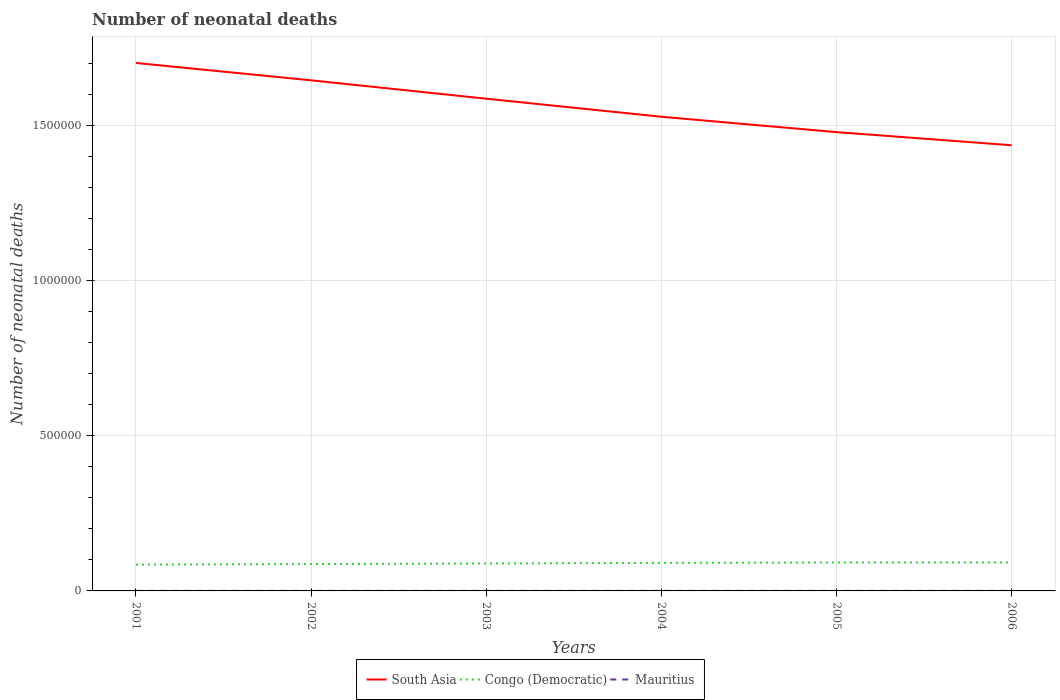Does the line corresponding to Congo (Democratic) intersect with the line corresponding to Mauritius?
Provide a succinct answer. No. Across all years, what is the maximum number of neonatal deaths in in Congo (Democratic)?
Your answer should be compact. 8.47e+04. What is the total number of neonatal deaths in in South Asia in the graph?
Your answer should be compact. 5.59e+04. What is the difference between the highest and the second highest number of neonatal deaths in in Congo (Democratic)?
Make the answer very short. 6965. What is the difference between the highest and the lowest number of neonatal deaths in in Mauritius?
Provide a short and direct response. 3. Is the number of neonatal deaths in in Congo (Democratic) strictly greater than the number of neonatal deaths in in Mauritius over the years?
Offer a terse response. No. What is the difference between two consecutive major ticks on the Y-axis?
Your answer should be very brief. 5.00e+05. Are the values on the major ticks of Y-axis written in scientific E-notation?
Provide a succinct answer. No. Does the graph contain any zero values?
Keep it short and to the point. No. Does the graph contain grids?
Give a very brief answer. Yes. Where does the legend appear in the graph?
Your response must be concise. Bottom center. How are the legend labels stacked?
Ensure brevity in your answer.  Horizontal. What is the title of the graph?
Your response must be concise. Number of neonatal deaths. What is the label or title of the Y-axis?
Make the answer very short. Number of neonatal deaths. What is the Number of neonatal deaths in South Asia in 2001?
Give a very brief answer. 1.70e+06. What is the Number of neonatal deaths of Congo (Democratic) in 2001?
Give a very brief answer. 8.47e+04. What is the Number of neonatal deaths in Mauritius in 2001?
Make the answer very short. 186. What is the Number of neonatal deaths of South Asia in 2002?
Your response must be concise. 1.65e+06. What is the Number of neonatal deaths in Congo (Democratic) in 2002?
Your answer should be compact. 8.65e+04. What is the Number of neonatal deaths of Mauritius in 2002?
Your answer should be compact. 181. What is the Number of neonatal deaths in South Asia in 2003?
Your response must be concise. 1.59e+06. What is the Number of neonatal deaths in Congo (Democratic) in 2003?
Offer a very short reply. 8.85e+04. What is the Number of neonatal deaths of Mauritius in 2003?
Make the answer very short. 188. What is the Number of neonatal deaths in South Asia in 2004?
Your answer should be very brief. 1.53e+06. What is the Number of neonatal deaths of Congo (Democratic) in 2004?
Ensure brevity in your answer.  9.03e+04. What is the Number of neonatal deaths of Mauritius in 2004?
Your answer should be compact. 196. What is the Number of neonatal deaths of South Asia in 2005?
Make the answer very short. 1.48e+06. What is the Number of neonatal deaths in Congo (Democratic) in 2005?
Provide a short and direct response. 9.16e+04. What is the Number of neonatal deaths in Mauritius in 2005?
Offer a very short reply. 201. What is the Number of neonatal deaths of South Asia in 2006?
Provide a short and direct response. 1.44e+06. What is the Number of neonatal deaths of Congo (Democratic) in 2006?
Your answer should be very brief. 9.17e+04. What is the Number of neonatal deaths in Mauritius in 2006?
Provide a short and direct response. 197. Across all years, what is the maximum Number of neonatal deaths in South Asia?
Your response must be concise. 1.70e+06. Across all years, what is the maximum Number of neonatal deaths of Congo (Democratic)?
Ensure brevity in your answer.  9.17e+04. Across all years, what is the maximum Number of neonatal deaths in Mauritius?
Make the answer very short. 201. Across all years, what is the minimum Number of neonatal deaths of South Asia?
Your response must be concise. 1.44e+06. Across all years, what is the minimum Number of neonatal deaths of Congo (Democratic)?
Give a very brief answer. 8.47e+04. Across all years, what is the minimum Number of neonatal deaths in Mauritius?
Your answer should be very brief. 181. What is the total Number of neonatal deaths in South Asia in the graph?
Give a very brief answer. 9.38e+06. What is the total Number of neonatal deaths in Congo (Democratic) in the graph?
Provide a succinct answer. 5.33e+05. What is the total Number of neonatal deaths of Mauritius in the graph?
Your answer should be compact. 1149. What is the difference between the Number of neonatal deaths of South Asia in 2001 and that in 2002?
Offer a very short reply. 5.59e+04. What is the difference between the Number of neonatal deaths in Congo (Democratic) in 2001 and that in 2002?
Provide a short and direct response. -1771. What is the difference between the Number of neonatal deaths in Mauritius in 2001 and that in 2002?
Offer a very short reply. 5. What is the difference between the Number of neonatal deaths of South Asia in 2001 and that in 2003?
Make the answer very short. 1.15e+05. What is the difference between the Number of neonatal deaths in Congo (Democratic) in 2001 and that in 2003?
Your answer should be compact. -3809. What is the difference between the Number of neonatal deaths of Mauritius in 2001 and that in 2003?
Offer a very short reply. -2. What is the difference between the Number of neonatal deaths of South Asia in 2001 and that in 2004?
Offer a terse response. 1.73e+05. What is the difference between the Number of neonatal deaths of Congo (Democratic) in 2001 and that in 2004?
Keep it short and to the point. -5583. What is the difference between the Number of neonatal deaths in South Asia in 2001 and that in 2005?
Your answer should be very brief. 2.23e+05. What is the difference between the Number of neonatal deaths of Congo (Democratic) in 2001 and that in 2005?
Make the answer very short. -6863. What is the difference between the Number of neonatal deaths of Mauritius in 2001 and that in 2005?
Give a very brief answer. -15. What is the difference between the Number of neonatal deaths of South Asia in 2001 and that in 2006?
Ensure brevity in your answer.  2.65e+05. What is the difference between the Number of neonatal deaths in Congo (Democratic) in 2001 and that in 2006?
Offer a very short reply. -6965. What is the difference between the Number of neonatal deaths of Mauritius in 2001 and that in 2006?
Ensure brevity in your answer.  -11. What is the difference between the Number of neonatal deaths in South Asia in 2002 and that in 2003?
Your answer should be very brief. 5.92e+04. What is the difference between the Number of neonatal deaths in Congo (Democratic) in 2002 and that in 2003?
Provide a succinct answer. -2038. What is the difference between the Number of neonatal deaths of Mauritius in 2002 and that in 2003?
Your answer should be compact. -7. What is the difference between the Number of neonatal deaths of South Asia in 2002 and that in 2004?
Your answer should be compact. 1.17e+05. What is the difference between the Number of neonatal deaths of Congo (Democratic) in 2002 and that in 2004?
Provide a short and direct response. -3812. What is the difference between the Number of neonatal deaths of Mauritius in 2002 and that in 2004?
Your response must be concise. -15. What is the difference between the Number of neonatal deaths in South Asia in 2002 and that in 2005?
Your response must be concise. 1.67e+05. What is the difference between the Number of neonatal deaths of Congo (Democratic) in 2002 and that in 2005?
Offer a terse response. -5092. What is the difference between the Number of neonatal deaths in South Asia in 2002 and that in 2006?
Offer a very short reply. 2.09e+05. What is the difference between the Number of neonatal deaths in Congo (Democratic) in 2002 and that in 2006?
Ensure brevity in your answer.  -5194. What is the difference between the Number of neonatal deaths in Mauritius in 2002 and that in 2006?
Ensure brevity in your answer.  -16. What is the difference between the Number of neonatal deaths in South Asia in 2003 and that in 2004?
Give a very brief answer. 5.82e+04. What is the difference between the Number of neonatal deaths in Congo (Democratic) in 2003 and that in 2004?
Ensure brevity in your answer.  -1774. What is the difference between the Number of neonatal deaths of Mauritius in 2003 and that in 2004?
Your response must be concise. -8. What is the difference between the Number of neonatal deaths of South Asia in 2003 and that in 2005?
Offer a terse response. 1.08e+05. What is the difference between the Number of neonatal deaths of Congo (Democratic) in 2003 and that in 2005?
Provide a short and direct response. -3054. What is the difference between the Number of neonatal deaths of South Asia in 2003 and that in 2006?
Your response must be concise. 1.50e+05. What is the difference between the Number of neonatal deaths in Congo (Democratic) in 2003 and that in 2006?
Your answer should be very brief. -3156. What is the difference between the Number of neonatal deaths in Mauritius in 2003 and that in 2006?
Your answer should be compact. -9. What is the difference between the Number of neonatal deaths of South Asia in 2004 and that in 2005?
Offer a terse response. 4.95e+04. What is the difference between the Number of neonatal deaths in Congo (Democratic) in 2004 and that in 2005?
Ensure brevity in your answer.  -1280. What is the difference between the Number of neonatal deaths of South Asia in 2004 and that in 2006?
Provide a short and direct response. 9.19e+04. What is the difference between the Number of neonatal deaths in Congo (Democratic) in 2004 and that in 2006?
Offer a very short reply. -1382. What is the difference between the Number of neonatal deaths of South Asia in 2005 and that in 2006?
Your answer should be compact. 4.23e+04. What is the difference between the Number of neonatal deaths of Congo (Democratic) in 2005 and that in 2006?
Offer a terse response. -102. What is the difference between the Number of neonatal deaths in South Asia in 2001 and the Number of neonatal deaths in Congo (Democratic) in 2002?
Provide a succinct answer. 1.61e+06. What is the difference between the Number of neonatal deaths in South Asia in 2001 and the Number of neonatal deaths in Mauritius in 2002?
Make the answer very short. 1.70e+06. What is the difference between the Number of neonatal deaths of Congo (Democratic) in 2001 and the Number of neonatal deaths of Mauritius in 2002?
Make the answer very short. 8.46e+04. What is the difference between the Number of neonatal deaths of South Asia in 2001 and the Number of neonatal deaths of Congo (Democratic) in 2003?
Offer a very short reply. 1.61e+06. What is the difference between the Number of neonatal deaths in South Asia in 2001 and the Number of neonatal deaths in Mauritius in 2003?
Your answer should be very brief. 1.70e+06. What is the difference between the Number of neonatal deaths of Congo (Democratic) in 2001 and the Number of neonatal deaths of Mauritius in 2003?
Your answer should be very brief. 8.46e+04. What is the difference between the Number of neonatal deaths in South Asia in 2001 and the Number of neonatal deaths in Congo (Democratic) in 2004?
Your answer should be compact. 1.61e+06. What is the difference between the Number of neonatal deaths of South Asia in 2001 and the Number of neonatal deaths of Mauritius in 2004?
Your answer should be very brief. 1.70e+06. What is the difference between the Number of neonatal deaths of Congo (Democratic) in 2001 and the Number of neonatal deaths of Mauritius in 2004?
Keep it short and to the point. 8.45e+04. What is the difference between the Number of neonatal deaths in South Asia in 2001 and the Number of neonatal deaths in Congo (Democratic) in 2005?
Offer a very short reply. 1.61e+06. What is the difference between the Number of neonatal deaths of South Asia in 2001 and the Number of neonatal deaths of Mauritius in 2005?
Your answer should be compact. 1.70e+06. What is the difference between the Number of neonatal deaths in Congo (Democratic) in 2001 and the Number of neonatal deaths in Mauritius in 2005?
Make the answer very short. 8.45e+04. What is the difference between the Number of neonatal deaths in South Asia in 2001 and the Number of neonatal deaths in Congo (Democratic) in 2006?
Offer a very short reply. 1.61e+06. What is the difference between the Number of neonatal deaths of South Asia in 2001 and the Number of neonatal deaths of Mauritius in 2006?
Provide a succinct answer. 1.70e+06. What is the difference between the Number of neonatal deaths of Congo (Democratic) in 2001 and the Number of neonatal deaths of Mauritius in 2006?
Provide a succinct answer. 8.45e+04. What is the difference between the Number of neonatal deaths in South Asia in 2002 and the Number of neonatal deaths in Congo (Democratic) in 2003?
Ensure brevity in your answer.  1.56e+06. What is the difference between the Number of neonatal deaths in South Asia in 2002 and the Number of neonatal deaths in Mauritius in 2003?
Your response must be concise. 1.65e+06. What is the difference between the Number of neonatal deaths of Congo (Democratic) in 2002 and the Number of neonatal deaths of Mauritius in 2003?
Offer a very short reply. 8.63e+04. What is the difference between the Number of neonatal deaths in South Asia in 2002 and the Number of neonatal deaths in Congo (Democratic) in 2004?
Your response must be concise. 1.56e+06. What is the difference between the Number of neonatal deaths in South Asia in 2002 and the Number of neonatal deaths in Mauritius in 2004?
Keep it short and to the point. 1.65e+06. What is the difference between the Number of neonatal deaths in Congo (Democratic) in 2002 and the Number of neonatal deaths in Mauritius in 2004?
Your response must be concise. 8.63e+04. What is the difference between the Number of neonatal deaths in South Asia in 2002 and the Number of neonatal deaths in Congo (Democratic) in 2005?
Offer a terse response. 1.55e+06. What is the difference between the Number of neonatal deaths of South Asia in 2002 and the Number of neonatal deaths of Mauritius in 2005?
Your response must be concise. 1.65e+06. What is the difference between the Number of neonatal deaths of Congo (Democratic) in 2002 and the Number of neonatal deaths of Mauritius in 2005?
Offer a very short reply. 8.63e+04. What is the difference between the Number of neonatal deaths in South Asia in 2002 and the Number of neonatal deaths in Congo (Democratic) in 2006?
Your answer should be compact. 1.55e+06. What is the difference between the Number of neonatal deaths in South Asia in 2002 and the Number of neonatal deaths in Mauritius in 2006?
Your answer should be compact. 1.65e+06. What is the difference between the Number of neonatal deaths in Congo (Democratic) in 2002 and the Number of neonatal deaths in Mauritius in 2006?
Give a very brief answer. 8.63e+04. What is the difference between the Number of neonatal deaths in South Asia in 2003 and the Number of neonatal deaths in Congo (Democratic) in 2004?
Keep it short and to the point. 1.50e+06. What is the difference between the Number of neonatal deaths of South Asia in 2003 and the Number of neonatal deaths of Mauritius in 2004?
Give a very brief answer. 1.59e+06. What is the difference between the Number of neonatal deaths of Congo (Democratic) in 2003 and the Number of neonatal deaths of Mauritius in 2004?
Your answer should be compact. 8.84e+04. What is the difference between the Number of neonatal deaths in South Asia in 2003 and the Number of neonatal deaths in Congo (Democratic) in 2005?
Offer a terse response. 1.49e+06. What is the difference between the Number of neonatal deaths in South Asia in 2003 and the Number of neonatal deaths in Mauritius in 2005?
Make the answer very short. 1.59e+06. What is the difference between the Number of neonatal deaths in Congo (Democratic) in 2003 and the Number of neonatal deaths in Mauritius in 2005?
Ensure brevity in your answer.  8.83e+04. What is the difference between the Number of neonatal deaths of South Asia in 2003 and the Number of neonatal deaths of Congo (Democratic) in 2006?
Offer a very short reply. 1.49e+06. What is the difference between the Number of neonatal deaths in South Asia in 2003 and the Number of neonatal deaths in Mauritius in 2006?
Your answer should be compact. 1.59e+06. What is the difference between the Number of neonatal deaths in Congo (Democratic) in 2003 and the Number of neonatal deaths in Mauritius in 2006?
Make the answer very short. 8.84e+04. What is the difference between the Number of neonatal deaths of South Asia in 2004 and the Number of neonatal deaths of Congo (Democratic) in 2005?
Your answer should be compact. 1.44e+06. What is the difference between the Number of neonatal deaths in South Asia in 2004 and the Number of neonatal deaths in Mauritius in 2005?
Ensure brevity in your answer.  1.53e+06. What is the difference between the Number of neonatal deaths of Congo (Democratic) in 2004 and the Number of neonatal deaths of Mauritius in 2005?
Provide a short and direct response. 9.01e+04. What is the difference between the Number of neonatal deaths of South Asia in 2004 and the Number of neonatal deaths of Congo (Democratic) in 2006?
Your response must be concise. 1.44e+06. What is the difference between the Number of neonatal deaths in South Asia in 2004 and the Number of neonatal deaths in Mauritius in 2006?
Your response must be concise. 1.53e+06. What is the difference between the Number of neonatal deaths of Congo (Democratic) in 2004 and the Number of neonatal deaths of Mauritius in 2006?
Provide a succinct answer. 9.01e+04. What is the difference between the Number of neonatal deaths in South Asia in 2005 and the Number of neonatal deaths in Congo (Democratic) in 2006?
Ensure brevity in your answer.  1.39e+06. What is the difference between the Number of neonatal deaths of South Asia in 2005 and the Number of neonatal deaths of Mauritius in 2006?
Your answer should be very brief. 1.48e+06. What is the difference between the Number of neonatal deaths in Congo (Democratic) in 2005 and the Number of neonatal deaths in Mauritius in 2006?
Offer a terse response. 9.14e+04. What is the average Number of neonatal deaths in South Asia per year?
Offer a terse response. 1.56e+06. What is the average Number of neonatal deaths of Congo (Democratic) per year?
Provide a short and direct response. 8.89e+04. What is the average Number of neonatal deaths in Mauritius per year?
Keep it short and to the point. 191.5. In the year 2001, what is the difference between the Number of neonatal deaths in South Asia and Number of neonatal deaths in Congo (Democratic)?
Offer a very short reply. 1.62e+06. In the year 2001, what is the difference between the Number of neonatal deaths in South Asia and Number of neonatal deaths in Mauritius?
Keep it short and to the point. 1.70e+06. In the year 2001, what is the difference between the Number of neonatal deaths of Congo (Democratic) and Number of neonatal deaths of Mauritius?
Give a very brief answer. 8.46e+04. In the year 2002, what is the difference between the Number of neonatal deaths of South Asia and Number of neonatal deaths of Congo (Democratic)?
Offer a very short reply. 1.56e+06. In the year 2002, what is the difference between the Number of neonatal deaths in South Asia and Number of neonatal deaths in Mauritius?
Your answer should be very brief. 1.65e+06. In the year 2002, what is the difference between the Number of neonatal deaths in Congo (Democratic) and Number of neonatal deaths in Mauritius?
Ensure brevity in your answer.  8.63e+04. In the year 2003, what is the difference between the Number of neonatal deaths of South Asia and Number of neonatal deaths of Congo (Democratic)?
Keep it short and to the point. 1.50e+06. In the year 2003, what is the difference between the Number of neonatal deaths of South Asia and Number of neonatal deaths of Mauritius?
Your answer should be very brief. 1.59e+06. In the year 2003, what is the difference between the Number of neonatal deaths of Congo (Democratic) and Number of neonatal deaths of Mauritius?
Give a very brief answer. 8.84e+04. In the year 2004, what is the difference between the Number of neonatal deaths of South Asia and Number of neonatal deaths of Congo (Democratic)?
Offer a very short reply. 1.44e+06. In the year 2004, what is the difference between the Number of neonatal deaths of South Asia and Number of neonatal deaths of Mauritius?
Provide a succinct answer. 1.53e+06. In the year 2004, what is the difference between the Number of neonatal deaths of Congo (Democratic) and Number of neonatal deaths of Mauritius?
Provide a short and direct response. 9.01e+04. In the year 2005, what is the difference between the Number of neonatal deaths of South Asia and Number of neonatal deaths of Congo (Democratic)?
Make the answer very short. 1.39e+06. In the year 2005, what is the difference between the Number of neonatal deaths of South Asia and Number of neonatal deaths of Mauritius?
Provide a succinct answer. 1.48e+06. In the year 2005, what is the difference between the Number of neonatal deaths in Congo (Democratic) and Number of neonatal deaths in Mauritius?
Offer a terse response. 9.14e+04. In the year 2006, what is the difference between the Number of neonatal deaths in South Asia and Number of neonatal deaths in Congo (Democratic)?
Offer a very short reply. 1.34e+06. In the year 2006, what is the difference between the Number of neonatal deaths of South Asia and Number of neonatal deaths of Mauritius?
Make the answer very short. 1.44e+06. In the year 2006, what is the difference between the Number of neonatal deaths of Congo (Democratic) and Number of neonatal deaths of Mauritius?
Provide a short and direct response. 9.15e+04. What is the ratio of the Number of neonatal deaths of South Asia in 2001 to that in 2002?
Provide a succinct answer. 1.03. What is the ratio of the Number of neonatal deaths of Congo (Democratic) in 2001 to that in 2002?
Provide a short and direct response. 0.98. What is the ratio of the Number of neonatal deaths in Mauritius in 2001 to that in 2002?
Provide a short and direct response. 1.03. What is the ratio of the Number of neonatal deaths in South Asia in 2001 to that in 2003?
Keep it short and to the point. 1.07. What is the ratio of the Number of neonatal deaths of Mauritius in 2001 to that in 2003?
Ensure brevity in your answer.  0.99. What is the ratio of the Number of neonatal deaths in South Asia in 2001 to that in 2004?
Keep it short and to the point. 1.11. What is the ratio of the Number of neonatal deaths in Congo (Democratic) in 2001 to that in 2004?
Make the answer very short. 0.94. What is the ratio of the Number of neonatal deaths in Mauritius in 2001 to that in 2004?
Provide a succinct answer. 0.95. What is the ratio of the Number of neonatal deaths of South Asia in 2001 to that in 2005?
Offer a terse response. 1.15. What is the ratio of the Number of neonatal deaths in Congo (Democratic) in 2001 to that in 2005?
Offer a terse response. 0.93. What is the ratio of the Number of neonatal deaths of Mauritius in 2001 to that in 2005?
Offer a very short reply. 0.93. What is the ratio of the Number of neonatal deaths in South Asia in 2001 to that in 2006?
Your response must be concise. 1.18. What is the ratio of the Number of neonatal deaths of Congo (Democratic) in 2001 to that in 2006?
Keep it short and to the point. 0.92. What is the ratio of the Number of neonatal deaths in Mauritius in 2001 to that in 2006?
Your answer should be compact. 0.94. What is the ratio of the Number of neonatal deaths of South Asia in 2002 to that in 2003?
Your response must be concise. 1.04. What is the ratio of the Number of neonatal deaths in Congo (Democratic) in 2002 to that in 2003?
Offer a terse response. 0.98. What is the ratio of the Number of neonatal deaths of Mauritius in 2002 to that in 2003?
Make the answer very short. 0.96. What is the ratio of the Number of neonatal deaths of South Asia in 2002 to that in 2004?
Offer a very short reply. 1.08. What is the ratio of the Number of neonatal deaths in Congo (Democratic) in 2002 to that in 2004?
Offer a terse response. 0.96. What is the ratio of the Number of neonatal deaths of Mauritius in 2002 to that in 2004?
Ensure brevity in your answer.  0.92. What is the ratio of the Number of neonatal deaths of South Asia in 2002 to that in 2005?
Give a very brief answer. 1.11. What is the ratio of the Number of neonatal deaths of Mauritius in 2002 to that in 2005?
Offer a terse response. 0.9. What is the ratio of the Number of neonatal deaths in South Asia in 2002 to that in 2006?
Keep it short and to the point. 1.15. What is the ratio of the Number of neonatal deaths of Congo (Democratic) in 2002 to that in 2006?
Make the answer very short. 0.94. What is the ratio of the Number of neonatal deaths of Mauritius in 2002 to that in 2006?
Give a very brief answer. 0.92. What is the ratio of the Number of neonatal deaths of South Asia in 2003 to that in 2004?
Offer a very short reply. 1.04. What is the ratio of the Number of neonatal deaths in Congo (Democratic) in 2003 to that in 2004?
Ensure brevity in your answer.  0.98. What is the ratio of the Number of neonatal deaths of Mauritius in 2003 to that in 2004?
Your answer should be compact. 0.96. What is the ratio of the Number of neonatal deaths in South Asia in 2003 to that in 2005?
Offer a terse response. 1.07. What is the ratio of the Number of neonatal deaths in Congo (Democratic) in 2003 to that in 2005?
Ensure brevity in your answer.  0.97. What is the ratio of the Number of neonatal deaths of Mauritius in 2003 to that in 2005?
Offer a terse response. 0.94. What is the ratio of the Number of neonatal deaths of South Asia in 2003 to that in 2006?
Your answer should be very brief. 1.1. What is the ratio of the Number of neonatal deaths of Congo (Democratic) in 2003 to that in 2006?
Provide a short and direct response. 0.97. What is the ratio of the Number of neonatal deaths in Mauritius in 2003 to that in 2006?
Provide a short and direct response. 0.95. What is the ratio of the Number of neonatal deaths in South Asia in 2004 to that in 2005?
Provide a short and direct response. 1.03. What is the ratio of the Number of neonatal deaths in Mauritius in 2004 to that in 2005?
Keep it short and to the point. 0.98. What is the ratio of the Number of neonatal deaths in South Asia in 2004 to that in 2006?
Keep it short and to the point. 1.06. What is the ratio of the Number of neonatal deaths of Congo (Democratic) in 2004 to that in 2006?
Keep it short and to the point. 0.98. What is the ratio of the Number of neonatal deaths in South Asia in 2005 to that in 2006?
Ensure brevity in your answer.  1.03. What is the ratio of the Number of neonatal deaths of Congo (Democratic) in 2005 to that in 2006?
Give a very brief answer. 1. What is the ratio of the Number of neonatal deaths of Mauritius in 2005 to that in 2006?
Ensure brevity in your answer.  1.02. What is the difference between the highest and the second highest Number of neonatal deaths in South Asia?
Offer a terse response. 5.59e+04. What is the difference between the highest and the second highest Number of neonatal deaths in Congo (Democratic)?
Give a very brief answer. 102. What is the difference between the highest and the lowest Number of neonatal deaths of South Asia?
Keep it short and to the point. 2.65e+05. What is the difference between the highest and the lowest Number of neonatal deaths of Congo (Democratic)?
Ensure brevity in your answer.  6965. 